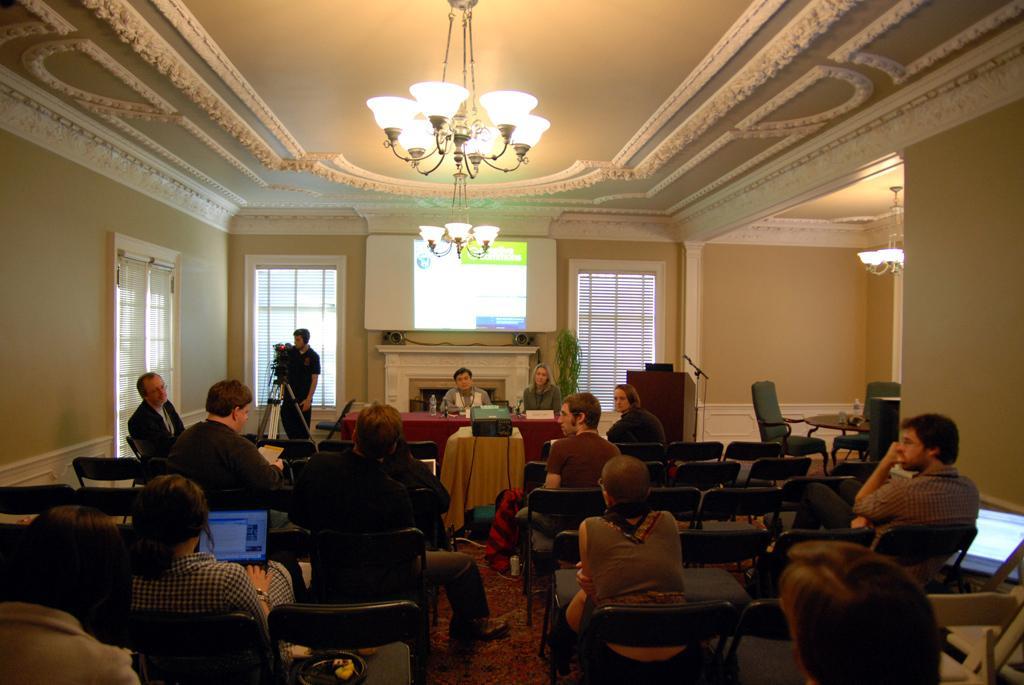Describe this image in one or two sentences. It is a room some people are sitting along with their laptops in front of them there is a projector in front of the projector there is a red color table and there are two people sitting in front of the table, behind them there is a wall and through the projector something is being displayed on the wall to the left side there is a cameraman with camera, in the background there are some windows and a cream color wall. 